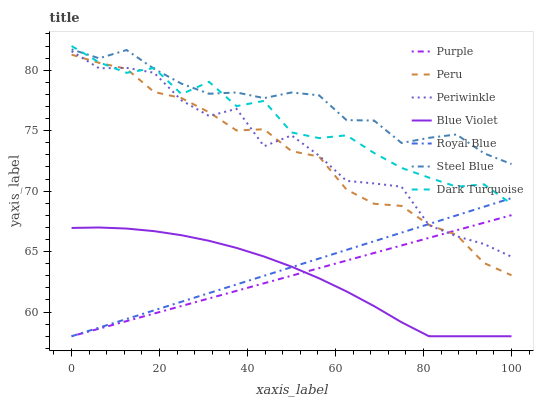Does Blue Violet have the minimum area under the curve?
Answer yes or no. Yes. Does Steel Blue have the maximum area under the curve?
Answer yes or no. Yes. Does Dark Turquoise have the minimum area under the curve?
Answer yes or no. No. Does Dark Turquoise have the maximum area under the curve?
Answer yes or no. No. Is Royal Blue the smoothest?
Answer yes or no. Yes. Is Periwinkle the roughest?
Answer yes or no. Yes. Is Dark Turquoise the smoothest?
Answer yes or no. No. Is Dark Turquoise the roughest?
Answer yes or no. No. Does Purple have the lowest value?
Answer yes or no. Yes. Does Dark Turquoise have the lowest value?
Answer yes or no. No. Does Dark Turquoise have the highest value?
Answer yes or no. Yes. Does Steel Blue have the highest value?
Answer yes or no. No. Is Purple less than Dark Turquoise?
Answer yes or no. Yes. Is Periwinkle greater than Blue Violet?
Answer yes or no. Yes. Does Royal Blue intersect Blue Violet?
Answer yes or no. Yes. Is Royal Blue less than Blue Violet?
Answer yes or no. No. Is Royal Blue greater than Blue Violet?
Answer yes or no. No. Does Purple intersect Dark Turquoise?
Answer yes or no. No. 